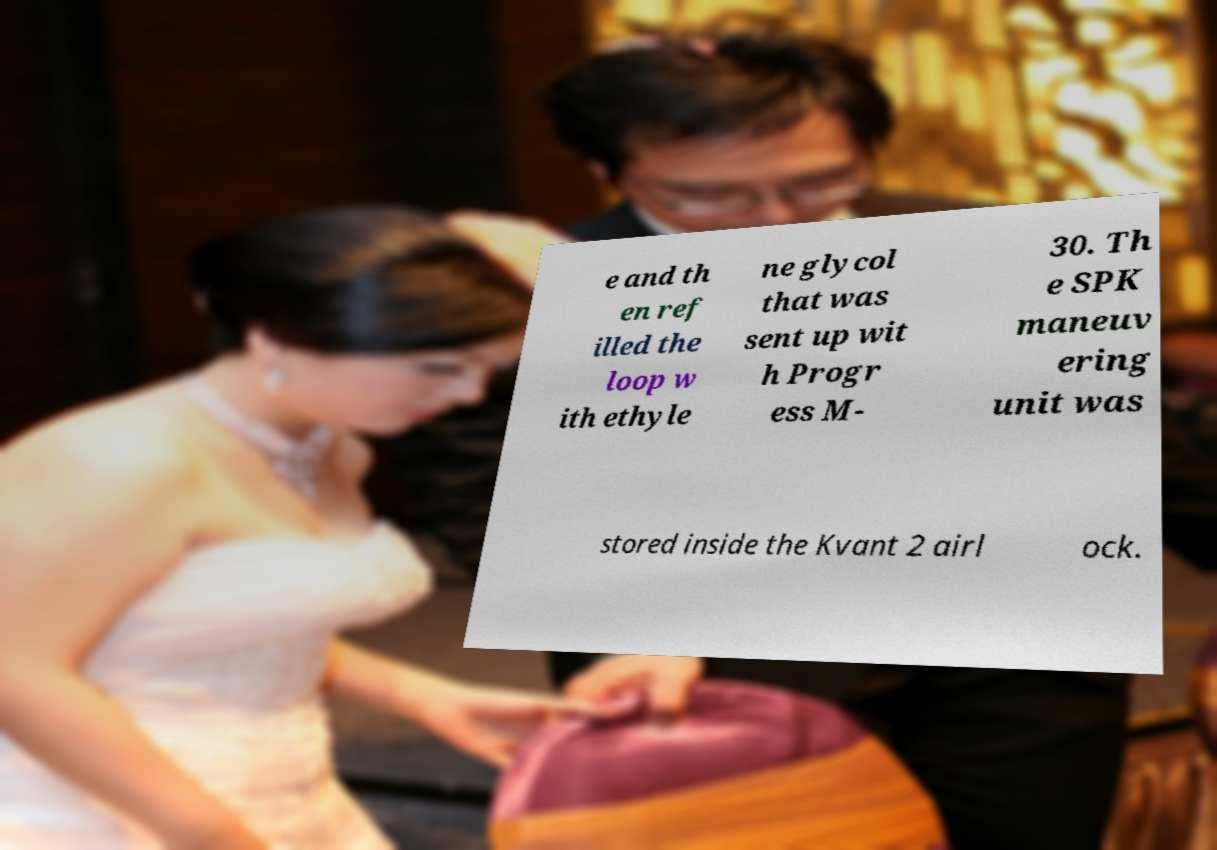What messages or text are displayed in this image? I need them in a readable, typed format. e and th en ref illed the loop w ith ethyle ne glycol that was sent up wit h Progr ess M- 30. Th e SPK maneuv ering unit was stored inside the Kvant 2 airl ock. 